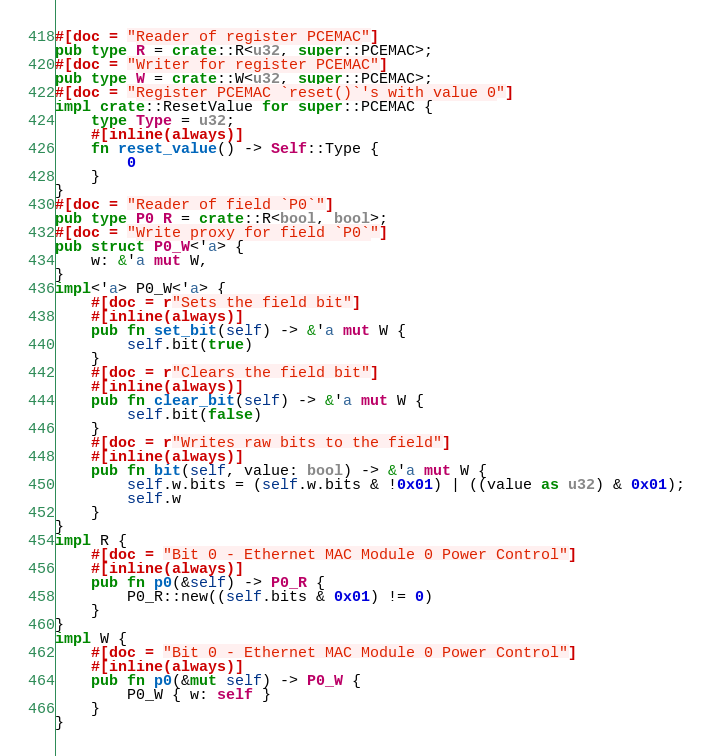<code> <loc_0><loc_0><loc_500><loc_500><_Rust_>#[doc = "Reader of register PCEMAC"]
pub type R = crate::R<u32, super::PCEMAC>;
#[doc = "Writer for register PCEMAC"]
pub type W = crate::W<u32, super::PCEMAC>;
#[doc = "Register PCEMAC `reset()`'s with value 0"]
impl crate::ResetValue for super::PCEMAC {
    type Type = u32;
    #[inline(always)]
    fn reset_value() -> Self::Type {
        0
    }
}
#[doc = "Reader of field `P0`"]
pub type P0_R = crate::R<bool, bool>;
#[doc = "Write proxy for field `P0`"]
pub struct P0_W<'a> {
    w: &'a mut W,
}
impl<'a> P0_W<'a> {
    #[doc = r"Sets the field bit"]
    #[inline(always)]
    pub fn set_bit(self) -> &'a mut W {
        self.bit(true)
    }
    #[doc = r"Clears the field bit"]
    #[inline(always)]
    pub fn clear_bit(self) -> &'a mut W {
        self.bit(false)
    }
    #[doc = r"Writes raw bits to the field"]
    #[inline(always)]
    pub fn bit(self, value: bool) -> &'a mut W {
        self.w.bits = (self.w.bits & !0x01) | ((value as u32) & 0x01);
        self.w
    }
}
impl R {
    #[doc = "Bit 0 - Ethernet MAC Module 0 Power Control"]
    #[inline(always)]
    pub fn p0(&self) -> P0_R {
        P0_R::new((self.bits & 0x01) != 0)
    }
}
impl W {
    #[doc = "Bit 0 - Ethernet MAC Module 0 Power Control"]
    #[inline(always)]
    pub fn p0(&mut self) -> P0_W {
        P0_W { w: self }
    }
}
</code> 